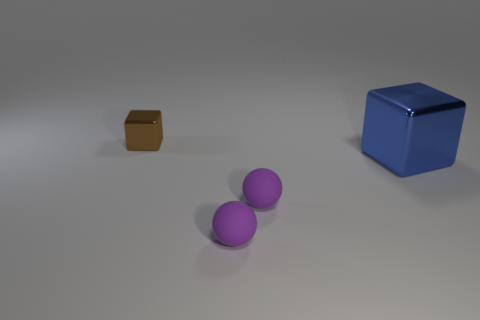What number of small things are either blue metal things or purple rubber objects?
Provide a short and direct response. 2. Are there any shiny things to the left of the big metallic block?
Make the answer very short. Yes. Are there the same number of purple balls that are behind the small cube and large things?
Give a very brief answer. No. What is the size of the blue object that is the same shape as the brown shiny object?
Ensure brevity in your answer.  Large. There is a blue metallic object; does it have the same shape as the metallic object behind the big blue metallic thing?
Offer a terse response. Yes. What is the size of the metal cube on the left side of the cube in front of the small shiny thing?
Offer a terse response. Small. Are there an equal number of tiny brown objects in front of the large blue block and purple objects in front of the small brown cube?
Your answer should be very brief. No. What color is the other object that is the same shape as the tiny metallic object?
Give a very brief answer. Blue. Do the small thing that is behind the large blue cube and the large blue metal object have the same shape?
Ensure brevity in your answer.  Yes. What is the size of the blue metal object?
Ensure brevity in your answer.  Large. 